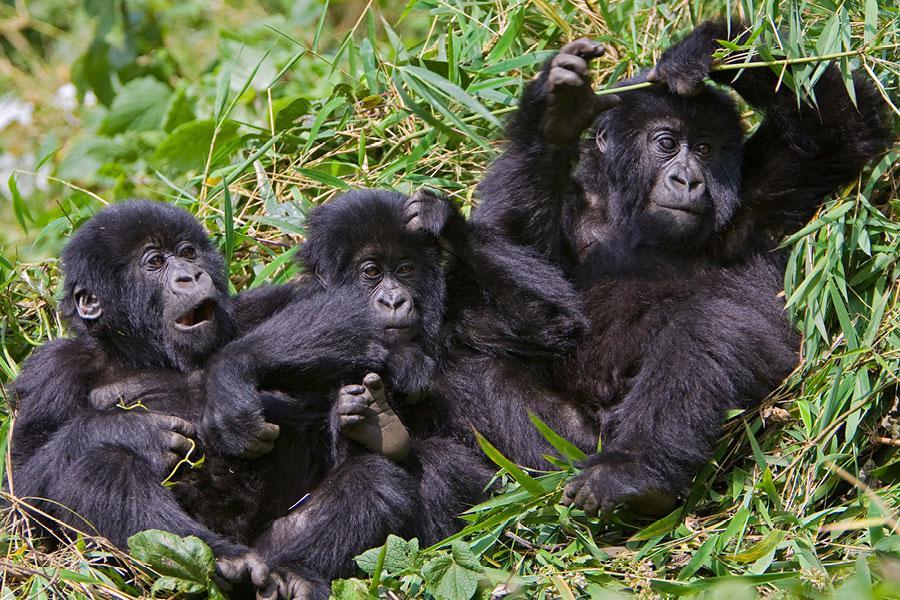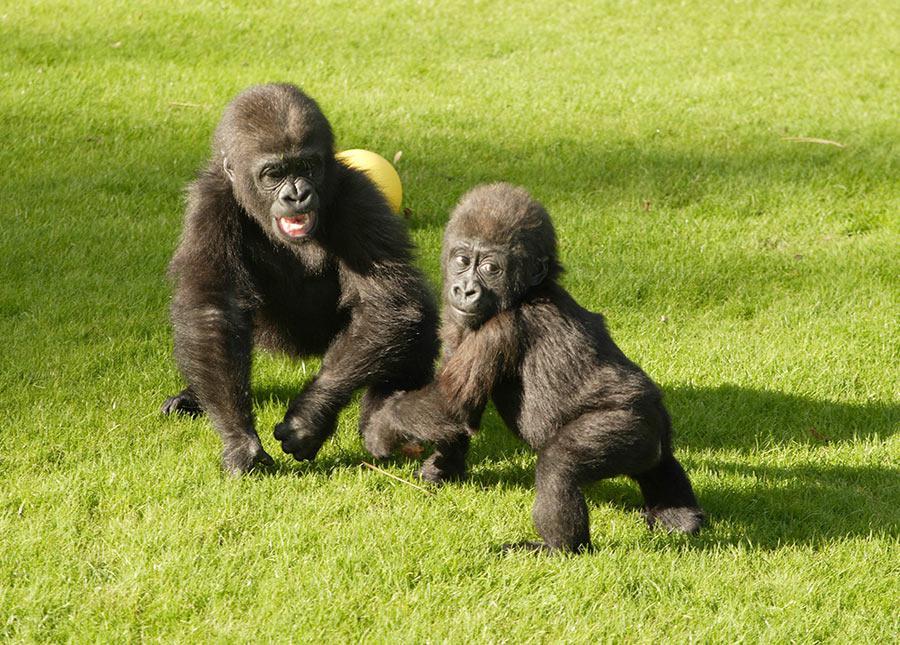The first image is the image on the left, the second image is the image on the right. For the images shown, is this caption "There are at most four gorillas." true? Answer yes or no. No. 